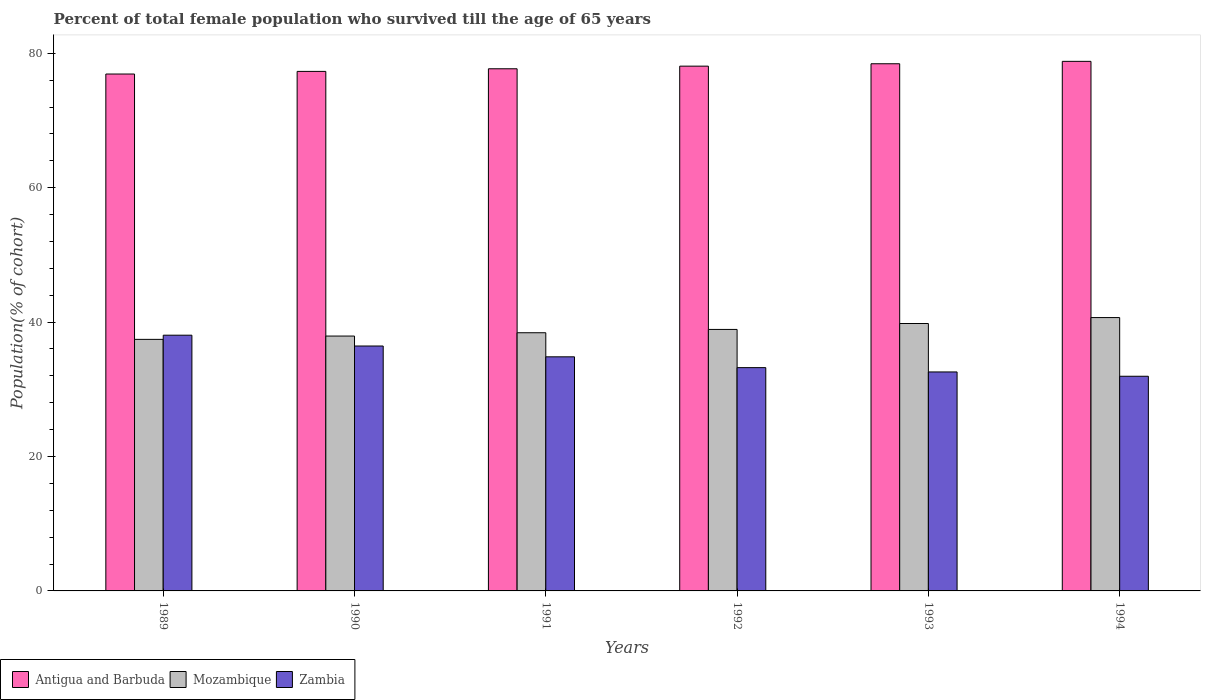How many different coloured bars are there?
Give a very brief answer. 3. How many groups of bars are there?
Make the answer very short. 6. Are the number of bars per tick equal to the number of legend labels?
Offer a terse response. Yes. Are the number of bars on each tick of the X-axis equal?
Offer a very short reply. Yes. How many bars are there on the 2nd tick from the right?
Your answer should be compact. 3. What is the label of the 4th group of bars from the left?
Provide a short and direct response. 1992. In how many cases, is the number of bars for a given year not equal to the number of legend labels?
Offer a very short reply. 0. What is the percentage of total female population who survived till the age of 65 years in Zambia in 1992?
Provide a short and direct response. 33.23. Across all years, what is the maximum percentage of total female population who survived till the age of 65 years in Antigua and Barbuda?
Provide a succinct answer. 78.8. Across all years, what is the minimum percentage of total female population who survived till the age of 65 years in Mozambique?
Make the answer very short. 37.43. In which year was the percentage of total female population who survived till the age of 65 years in Zambia maximum?
Your answer should be compact. 1989. In which year was the percentage of total female population who survived till the age of 65 years in Antigua and Barbuda minimum?
Provide a short and direct response. 1989. What is the total percentage of total female population who survived till the age of 65 years in Antigua and Barbuda in the graph?
Keep it short and to the point. 467.25. What is the difference between the percentage of total female population who survived till the age of 65 years in Zambia in 1990 and that in 1991?
Your answer should be compact. 1.61. What is the difference between the percentage of total female population who survived till the age of 65 years in Zambia in 1993 and the percentage of total female population who survived till the age of 65 years in Antigua and Barbuda in 1991?
Ensure brevity in your answer.  -45.11. What is the average percentage of total female population who survived till the age of 65 years in Antigua and Barbuda per year?
Keep it short and to the point. 77.88. In the year 1991, what is the difference between the percentage of total female population who survived till the age of 65 years in Zambia and percentage of total female population who survived till the age of 65 years in Mozambique?
Offer a very short reply. -3.58. What is the ratio of the percentage of total female population who survived till the age of 65 years in Antigua and Barbuda in 1990 to that in 1994?
Provide a short and direct response. 0.98. Is the percentage of total female population who survived till the age of 65 years in Mozambique in 1993 less than that in 1994?
Make the answer very short. Yes. Is the difference between the percentage of total female population who survived till the age of 65 years in Zambia in 1993 and 1994 greater than the difference between the percentage of total female population who survived till the age of 65 years in Mozambique in 1993 and 1994?
Provide a succinct answer. Yes. What is the difference between the highest and the second highest percentage of total female population who survived till the age of 65 years in Zambia?
Give a very brief answer. 1.61. What is the difference between the highest and the lowest percentage of total female population who survived till the age of 65 years in Zambia?
Your answer should be very brief. 6.11. In how many years, is the percentage of total female population who survived till the age of 65 years in Antigua and Barbuda greater than the average percentage of total female population who survived till the age of 65 years in Antigua and Barbuda taken over all years?
Provide a succinct answer. 3. Is the sum of the percentage of total female population who survived till the age of 65 years in Antigua and Barbuda in 1991 and 1992 greater than the maximum percentage of total female population who survived till the age of 65 years in Zambia across all years?
Offer a terse response. Yes. What does the 2nd bar from the left in 1989 represents?
Your answer should be very brief. Mozambique. What does the 1st bar from the right in 1993 represents?
Give a very brief answer. Zambia. How many bars are there?
Your answer should be very brief. 18. Does the graph contain grids?
Offer a very short reply. No. Where does the legend appear in the graph?
Keep it short and to the point. Bottom left. What is the title of the graph?
Keep it short and to the point. Percent of total female population who survived till the age of 65 years. Does "Tonga" appear as one of the legend labels in the graph?
Give a very brief answer. No. What is the label or title of the Y-axis?
Ensure brevity in your answer.  Population(% of cohort). What is the Population(% of cohort) in Antigua and Barbuda in 1989?
Give a very brief answer. 76.92. What is the Population(% of cohort) in Mozambique in 1989?
Your answer should be compact. 37.43. What is the Population(% of cohort) in Zambia in 1989?
Offer a very short reply. 38.05. What is the Population(% of cohort) in Antigua and Barbuda in 1990?
Keep it short and to the point. 77.31. What is the Population(% of cohort) of Mozambique in 1990?
Offer a terse response. 37.92. What is the Population(% of cohort) of Zambia in 1990?
Your answer should be compact. 36.44. What is the Population(% of cohort) in Antigua and Barbuda in 1991?
Your answer should be very brief. 77.7. What is the Population(% of cohort) of Mozambique in 1991?
Your answer should be very brief. 38.42. What is the Population(% of cohort) of Zambia in 1991?
Your answer should be very brief. 34.84. What is the Population(% of cohort) of Antigua and Barbuda in 1992?
Ensure brevity in your answer.  78.09. What is the Population(% of cohort) of Mozambique in 1992?
Your answer should be compact. 38.91. What is the Population(% of cohort) in Zambia in 1992?
Offer a terse response. 33.23. What is the Population(% of cohort) of Antigua and Barbuda in 1993?
Give a very brief answer. 78.44. What is the Population(% of cohort) of Mozambique in 1993?
Make the answer very short. 39.79. What is the Population(% of cohort) in Zambia in 1993?
Your answer should be compact. 32.58. What is the Population(% of cohort) of Antigua and Barbuda in 1994?
Offer a terse response. 78.8. What is the Population(% of cohort) in Mozambique in 1994?
Make the answer very short. 40.67. What is the Population(% of cohort) of Zambia in 1994?
Offer a very short reply. 31.94. Across all years, what is the maximum Population(% of cohort) in Antigua and Barbuda?
Give a very brief answer. 78.8. Across all years, what is the maximum Population(% of cohort) in Mozambique?
Keep it short and to the point. 40.67. Across all years, what is the maximum Population(% of cohort) in Zambia?
Provide a short and direct response. 38.05. Across all years, what is the minimum Population(% of cohort) in Antigua and Barbuda?
Make the answer very short. 76.92. Across all years, what is the minimum Population(% of cohort) of Mozambique?
Provide a short and direct response. 37.43. Across all years, what is the minimum Population(% of cohort) of Zambia?
Offer a terse response. 31.94. What is the total Population(% of cohort) of Antigua and Barbuda in the graph?
Your answer should be very brief. 467.25. What is the total Population(% of cohort) in Mozambique in the graph?
Ensure brevity in your answer.  233.15. What is the total Population(% of cohort) of Zambia in the graph?
Give a very brief answer. 207.09. What is the difference between the Population(% of cohort) of Antigua and Barbuda in 1989 and that in 1990?
Keep it short and to the point. -0.39. What is the difference between the Population(% of cohort) in Mozambique in 1989 and that in 1990?
Make the answer very short. -0.49. What is the difference between the Population(% of cohort) in Zambia in 1989 and that in 1990?
Your answer should be very brief. 1.61. What is the difference between the Population(% of cohort) in Antigua and Barbuda in 1989 and that in 1991?
Provide a short and direct response. -0.78. What is the difference between the Population(% of cohort) in Mozambique in 1989 and that in 1991?
Keep it short and to the point. -0.99. What is the difference between the Population(% of cohort) of Zambia in 1989 and that in 1991?
Provide a short and direct response. 3.22. What is the difference between the Population(% of cohort) of Antigua and Barbuda in 1989 and that in 1992?
Your response must be concise. -1.17. What is the difference between the Population(% of cohort) in Mozambique in 1989 and that in 1992?
Your answer should be very brief. -1.48. What is the difference between the Population(% of cohort) of Zambia in 1989 and that in 1992?
Give a very brief answer. 4.83. What is the difference between the Population(% of cohort) in Antigua and Barbuda in 1989 and that in 1993?
Offer a terse response. -1.53. What is the difference between the Population(% of cohort) in Mozambique in 1989 and that in 1993?
Your answer should be compact. -2.36. What is the difference between the Population(% of cohort) of Zambia in 1989 and that in 1993?
Offer a terse response. 5.47. What is the difference between the Population(% of cohort) in Antigua and Barbuda in 1989 and that in 1994?
Your answer should be very brief. -1.89. What is the difference between the Population(% of cohort) of Mozambique in 1989 and that in 1994?
Your response must be concise. -3.24. What is the difference between the Population(% of cohort) of Zambia in 1989 and that in 1994?
Your answer should be very brief. 6.11. What is the difference between the Population(% of cohort) in Antigua and Barbuda in 1990 and that in 1991?
Your answer should be compact. -0.39. What is the difference between the Population(% of cohort) of Mozambique in 1990 and that in 1991?
Provide a succinct answer. -0.49. What is the difference between the Population(% of cohort) of Zambia in 1990 and that in 1991?
Your answer should be compact. 1.61. What is the difference between the Population(% of cohort) in Antigua and Barbuda in 1990 and that in 1992?
Give a very brief answer. -0.78. What is the difference between the Population(% of cohort) of Mozambique in 1990 and that in 1992?
Give a very brief answer. -0.99. What is the difference between the Population(% of cohort) of Zambia in 1990 and that in 1992?
Ensure brevity in your answer.  3.22. What is the difference between the Population(% of cohort) in Antigua and Barbuda in 1990 and that in 1993?
Your answer should be compact. -1.14. What is the difference between the Population(% of cohort) in Mozambique in 1990 and that in 1993?
Offer a terse response. -1.87. What is the difference between the Population(% of cohort) in Zambia in 1990 and that in 1993?
Make the answer very short. 3.86. What is the difference between the Population(% of cohort) of Antigua and Barbuda in 1990 and that in 1994?
Keep it short and to the point. -1.5. What is the difference between the Population(% of cohort) in Mozambique in 1990 and that in 1994?
Make the answer very short. -2.75. What is the difference between the Population(% of cohort) of Zambia in 1990 and that in 1994?
Provide a short and direct response. 4.5. What is the difference between the Population(% of cohort) of Antigua and Barbuda in 1991 and that in 1992?
Your answer should be compact. -0.39. What is the difference between the Population(% of cohort) in Mozambique in 1991 and that in 1992?
Keep it short and to the point. -0.49. What is the difference between the Population(% of cohort) in Zambia in 1991 and that in 1992?
Ensure brevity in your answer.  1.61. What is the difference between the Population(% of cohort) in Antigua and Barbuda in 1991 and that in 1993?
Give a very brief answer. -0.75. What is the difference between the Population(% of cohort) of Mozambique in 1991 and that in 1993?
Offer a very short reply. -1.38. What is the difference between the Population(% of cohort) of Zambia in 1991 and that in 1993?
Make the answer very short. 2.25. What is the difference between the Population(% of cohort) in Antigua and Barbuda in 1991 and that in 1994?
Your response must be concise. -1.1. What is the difference between the Population(% of cohort) of Mozambique in 1991 and that in 1994?
Your response must be concise. -2.26. What is the difference between the Population(% of cohort) in Zambia in 1991 and that in 1994?
Offer a very short reply. 2.89. What is the difference between the Population(% of cohort) in Antigua and Barbuda in 1992 and that in 1993?
Offer a terse response. -0.36. What is the difference between the Population(% of cohort) in Mozambique in 1992 and that in 1993?
Your answer should be very brief. -0.88. What is the difference between the Population(% of cohort) in Zambia in 1992 and that in 1993?
Provide a short and direct response. 0.64. What is the difference between the Population(% of cohort) of Antigua and Barbuda in 1992 and that in 1994?
Your answer should be very brief. -0.71. What is the difference between the Population(% of cohort) in Mozambique in 1992 and that in 1994?
Offer a terse response. -1.77. What is the difference between the Population(% of cohort) in Zambia in 1992 and that in 1994?
Provide a succinct answer. 1.28. What is the difference between the Population(% of cohort) of Antigua and Barbuda in 1993 and that in 1994?
Your response must be concise. -0.36. What is the difference between the Population(% of cohort) of Mozambique in 1993 and that in 1994?
Keep it short and to the point. -0.88. What is the difference between the Population(% of cohort) of Zambia in 1993 and that in 1994?
Give a very brief answer. 0.64. What is the difference between the Population(% of cohort) of Antigua and Barbuda in 1989 and the Population(% of cohort) of Mozambique in 1990?
Give a very brief answer. 38.99. What is the difference between the Population(% of cohort) in Antigua and Barbuda in 1989 and the Population(% of cohort) in Zambia in 1990?
Provide a succinct answer. 40.47. What is the difference between the Population(% of cohort) in Mozambique in 1989 and the Population(% of cohort) in Zambia in 1990?
Give a very brief answer. 0.99. What is the difference between the Population(% of cohort) in Antigua and Barbuda in 1989 and the Population(% of cohort) in Mozambique in 1991?
Offer a very short reply. 38.5. What is the difference between the Population(% of cohort) of Antigua and Barbuda in 1989 and the Population(% of cohort) of Zambia in 1991?
Your answer should be very brief. 42.08. What is the difference between the Population(% of cohort) of Mozambique in 1989 and the Population(% of cohort) of Zambia in 1991?
Ensure brevity in your answer.  2.6. What is the difference between the Population(% of cohort) in Antigua and Barbuda in 1989 and the Population(% of cohort) in Mozambique in 1992?
Provide a short and direct response. 38.01. What is the difference between the Population(% of cohort) in Antigua and Barbuda in 1989 and the Population(% of cohort) in Zambia in 1992?
Provide a short and direct response. 43.69. What is the difference between the Population(% of cohort) of Mozambique in 1989 and the Population(% of cohort) of Zambia in 1992?
Your answer should be very brief. 4.21. What is the difference between the Population(% of cohort) in Antigua and Barbuda in 1989 and the Population(% of cohort) in Mozambique in 1993?
Your answer should be very brief. 37.12. What is the difference between the Population(% of cohort) in Antigua and Barbuda in 1989 and the Population(% of cohort) in Zambia in 1993?
Make the answer very short. 44.33. What is the difference between the Population(% of cohort) in Mozambique in 1989 and the Population(% of cohort) in Zambia in 1993?
Your response must be concise. 4.85. What is the difference between the Population(% of cohort) in Antigua and Barbuda in 1989 and the Population(% of cohort) in Mozambique in 1994?
Keep it short and to the point. 36.24. What is the difference between the Population(% of cohort) of Antigua and Barbuda in 1989 and the Population(% of cohort) of Zambia in 1994?
Your response must be concise. 44.97. What is the difference between the Population(% of cohort) of Mozambique in 1989 and the Population(% of cohort) of Zambia in 1994?
Keep it short and to the point. 5.49. What is the difference between the Population(% of cohort) of Antigua and Barbuda in 1990 and the Population(% of cohort) of Mozambique in 1991?
Provide a short and direct response. 38.89. What is the difference between the Population(% of cohort) in Antigua and Barbuda in 1990 and the Population(% of cohort) in Zambia in 1991?
Offer a very short reply. 42.47. What is the difference between the Population(% of cohort) in Mozambique in 1990 and the Population(% of cohort) in Zambia in 1991?
Your response must be concise. 3.09. What is the difference between the Population(% of cohort) of Antigua and Barbuda in 1990 and the Population(% of cohort) of Mozambique in 1992?
Make the answer very short. 38.4. What is the difference between the Population(% of cohort) of Antigua and Barbuda in 1990 and the Population(% of cohort) of Zambia in 1992?
Provide a short and direct response. 44.08. What is the difference between the Population(% of cohort) in Mozambique in 1990 and the Population(% of cohort) in Zambia in 1992?
Offer a terse response. 4.7. What is the difference between the Population(% of cohort) of Antigua and Barbuda in 1990 and the Population(% of cohort) of Mozambique in 1993?
Give a very brief answer. 37.51. What is the difference between the Population(% of cohort) in Antigua and Barbuda in 1990 and the Population(% of cohort) in Zambia in 1993?
Provide a short and direct response. 44.72. What is the difference between the Population(% of cohort) of Mozambique in 1990 and the Population(% of cohort) of Zambia in 1993?
Provide a succinct answer. 5.34. What is the difference between the Population(% of cohort) in Antigua and Barbuda in 1990 and the Population(% of cohort) in Mozambique in 1994?
Provide a succinct answer. 36.63. What is the difference between the Population(% of cohort) of Antigua and Barbuda in 1990 and the Population(% of cohort) of Zambia in 1994?
Your answer should be compact. 45.36. What is the difference between the Population(% of cohort) in Mozambique in 1990 and the Population(% of cohort) in Zambia in 1994?
Your answer should be compact. 5.98. What is the difference between the Population(% of cohort) in Antigua and Barbuda in 1991 and the Population(% of cohort) in Mozambique in 1992?
Give a very brief answer. 38.79. What is the difference between the Population(% of cohort) in Antigua and Barbuda in 1991 and the Population(% of cohort) in Zambia in 1992?
Your answer should be very brief. 44.47. What is the difference between the Population(% of cohort) in Mozambique in 1991 and the Population(% of cohort) in Zambia in 1992?
Keep it short and to the point. 5.19. What is the difference between the Population(% of cohort) of Antigua and Barbuda in 1991 and the Population(% of cohort) of Mozambique in 1993?
Your answer should be very brief. 37.9. What is the difference between the Population(% of cohort) in Antigua and Barbuda in 1991 and the Population(% of cohort) in Zambia in 1993?
Your response must be concise. 45.11. What is the difference between the Population(% of cohort) of Mozambique in 1991 and the Population(% of cohort) of Zambia in 1993?
Offer a terse response. 5.83. What is the difference between the Population(% of cohort) in Antigua and Barbuda in 1991 and the Population(% of cohort) in Mozambique in 1994?
Offer a very short reply. 37.02. What is the difference between the Population(% of cohort) of Antigua and Barbuda in 1991 and the Population(% of cohort) of Zambia in 1994?
Give a very brief answer. 45.75. What is the difference between the Population(% of cohort) in Mozambique in 1991 and the Population(% of cohort) in Zambia in 1994?
Your response must be concise. 6.47. What is the difference between the Population(% of cohort) in Antigua and Barbuda in 1992 and the Population(% of cohort) in Mozambique in 1993?
Your answer should be very brief. 38.29. What is the difference between the Population(% of cohort) of Antigua and Barbuda in 1992 and the Population(% of cohort) of Zambia in 1993?
Your response must be concise. 45.5. What is the difference between the Population(% of cohort) in Mozambique in 1992 and the Population(% of cohort) in Zambia in 1993?
Offer a very short reply. 6.33. What is the difference between the Population(% of cohort) of Antigua and Barbuda in 1992 and the Population(% of cohort) of Mozambique in 1994?
Provide a succinct answer. 37.41. What is the difference between the Population(% of cohort) of Antigua and Barbuda in 1992 and the Population(% of cohort) of Zambia in 1994?
Provide a succinct answer. 46.14. What is the difference between the Population(% of cohort) in Mozambique in 1992 and the Population(% of cohort) in Zambia in 1994?
Provide a short and direct response. 6.97. What is the difference between the Population(% of cohort) of Antigua and Barbuda in 1993 and the Population(% of cohort) of Mozambique in 1994?
Keep it short and to the point. 37.77. What is the difference between the Population(% of cohort) in Antigua and Barbuda in 1993 and the Population(% of cohort) in Zambia in 1994?
Your response must be concise. 46.5. What is the difference between the Population(% of cohort) in Mozambique in 1993 and the Population(% of cohort) in Zambia in 1994?
Your answer should be very brief. 7.85. What is the average Population(% of cohort) of Antigua and Barbuda per year?
Offer a very short reply. 77.88. What is the average Population(% of cohort) of Mozambique per year?
Keep it short and to the point. 38.86. What is the average Population(% of cohort) of Zambia per year?
Your response must be concise. 34.51. In the year 1989, what is the difference between the Population(% of cohort) in Antigua and Barbuda and Population(% of cohort) in Mozambique?
Give a very brief answer. 39.48. In the year 1989, what is the difference between the Population(% of cohort) in Antigua and Barbuda and Population(% of cohort) in Zambia?
Your answer should be very brief. 38.86. In the year 1989, what is the difference between the Population(% of cohort) in Mozambique and Population(% of cohort) in Zambia?
Make the answer very short. -0.62. In the year 1990, what is the difference between the Population(% of cohort) of Antigua and Barbuda and Population(% of cohort) of Mozambique?
Keep it short and to the point. 39.38. In the year 1990, what is the difference between the Population(% of cohort) in Antigua and Barbuda and Population(% of cohort) in Zambia?
Offer a very short reply. 40.86. In the year 1990, what is the difference between the Population(% of cohort) of Mozambique and Population(% of cohort) of Zambia?
Your answer should be very brief. 1.48. In the year 1991, what is the difference between the Population(% of cohort) in Antigua and Barbuda and Population(% of cohort) in Mozambique?
Make the answer very short. 39.28. In the year 1991, what is the difference between the Population(% of cohort) of Antigua and Barbuda and Population(% of cohort) of Zambia?
Your answer should be compact. 42.86. In the year 1991, what is the difference between the Population(% of cohort) of Mozambique and Population(% of cohort) of Zambia?
Make the answer very short. 3.58. In the year 1992, what is the difference between the Population(% of cohort) in Antigua and Barbuda and Population(% of cohort) in Mozambique?
Offer a terse response. 39.18. In the year 1992, what is the difference between the Population(% of cohort) in Antigua and Barbuda and Population(% of cohort) in Zambia?
Provide a succinct answer. 44.86. In the year 1992, what is the difference between the Population(% of cohort) in Mozambique and Population(% of cohort) in Zambia?
Keep it short and to the point. 5.68. In the year 1993, what is the difference between the Population(% of cohort) in Antigua and Barbuda and Population(% of cohort) in Mozambique?
Provide a succinct answer. 38.65. In the year 1993, what is the difference between the Population(% of cohort) of Antigua and Barbuda and Population(% of cohort) of Zambia?
Provide a succinct answer. 45.86. In the year 1993, what is the difference between the Population(% of cohort) of Mozambique and Population(% of cohort) of Zambia?
Make the answer very short. 7.21. In the year 1994, what is the difference between the Population(% of cohort) in Antigua and Barbuda and Population(% of cohort) in Mozambique?
Keep it short and to the point. 38.13. In the year 1994, what is the difference between the Population(% of cohort) in Antigua and Barbuda and Population(% of cohort) in Zambia?
Give a very brief answer. 46.86. In the year 1994, what is the difference between the Population(% of cohort) in Mozambique and Population(% of cohort) in Zambia?
Provide a succinct answer. 8.73. What is the ratio of the Population(% of cohort) in Zambia in 1989 to that in 1990?
Keep it short and to the point. 1.04. What is the ratio of the Population(% of cohort) in Antigua and Barbuda in 1989 to that in 1991?
Give a very brief answer. 0.99. What is the ratio of the Population(% of cohort) in Mozambique in 1989 to that in 1991?
Give a very brief answer. 0.97. What is the ratio of the Population(% of cohort) in Zambia in 1989 to that in 1991?
Provide a short and direct response. 1.09. What is the ratio of the Population(% of cohort) of Zambia in 1989 to that in 1992?
Your response must be concise. 1.15. What is the ratio of the Population(% of cohort) of Antigua and Barbuda in 1989 to that in 1993?
Offer a terse response. 0.98. What is the ratio of the Population(% of cohort) of Mozambique in 1989 to that in 1993?
Your response must be concise. 0.94. What is the ratio of the Population(% of cohort) in Zambia in 1989 to that in 1993?
Your response must be concise. 1.17. What is the ratio of the Population(% of cohort) in Antigua and Barbuda in 1989 to that in 1994?
Make the answer very short. 0.98. What is the ratio of the Population(% of cohort) of Mozambique in 1989 to that in 1994?
Your answer should be very brief. 0.92. What is the ratio of the Population(% of cohort) of Zambia in 1989 to that in 1994?
Offer a terse response. 1.19. What is the ratio of the Population(% of cohort) in Antigua and Barbuda in 1990 to that in 1991?
Keep it short and to the point. 0.99. What is the ratio of the Population(% of cohort) in Mozambique in 1990 to that in 1991?
Offer a very short reply. 0.99. What is the ratio of the Population(% of cohort) of Zambia in 1990 to that in 1991?
Keep it short and to the point. 1.05. What is the ratio of the Population(% of cohort) of Mozambique in 1990 to that in 1992?
Make the answer very short. 0.97. What is the ratio of the Population(% of cohort) in Zambia in 1990 to that in 1992?
Ensure brevity in your answer.  1.1. What is the ratio of the Population(% of cohort) in Antigua and Barbuda in 1990 to that in 1993?
Your response must be concise. 0.99. What is the ratio of the Population(% of cohort) in Mozambique in 1990 to that in 1993?
Offer a very short reply. 0.95. What is the ratio of the Population(% of cohort) of Zambia in 1990 to that in 1993?
Offer a very short reply. 1.12. What is the ratio of the Population(% of cohort) of Antigua and Barbuda in 1990 to that in 1994?
Your answer should be very brief. 0.98. What is the ratio of the Population(% of cohort) in Mozambique in 1990 to that in 1994?
Your answer should be compact. 0.93. What is the ratio of the Population(% of cohort) in Zambia in 1990 to that in 1994?
Keep it short and to the point. 1.14. What is the ratio of the Population(% of cohort) in Mozambique in 1991 to that in 1992?
Keep it short and to the point. 0.99. What is the ratio of the Population(% of cohort) of Zambia in 1991 to that in 1992?
Provide a short and direct response. 1.05. What is the ratio of the Population(% of cohort) in Mozambique in 1991 to that in 1993?
Your answer should be very brief. 0.97. What is the ratio of the Population(% of cohort) in Zambia in 1991 to that in 1993?
Provide a short and direct response. 1.07. What is the ratio of the Population(% of cohort) in Antigua and Barbuda in 1991 to that in 1994?
Your response must be concise. 0.99. What is the ratio of the Population(% of cohort) of Mozambique in 1991 to that in 1994?
Keep it short and to the point. 0.94. What is the ratio of the Population(% of cohort) in Zambia in 1991 to that in 1994?
Provide a short and direct response. 1.09. What is the ratio of the Population(% of cohort) of Mozambique in 1992 to that in 1993?
Ensure brevity in your answer.  0.98. What is the ratio of the Population(% of cohort) of Zambia in 1992 to that in 1993?
Your answer should be very brief. 1.02. What is the ratio of the Population(% of cohort) of Antigua and Barbuda in 1992 to that in 1994?
Offer a terse response. 0.99. What is the ratio of the Population(% of cohort) in Mozambique in 1992 to that in 1994?
Ensure brevity in your answer.  0.96. What is the ratio of the Population(% of cohort) in Zambia in 1992 to that in 1994?
Provide a succinct answer. 1.04. What is the ratio of the Population(% of cohort) in Mozambique in 1993 to that in 1994?
Keep it short and to the point. 0.98. What is the ratio of the Population(% of cohort) in Zambia in 1993 to that in 1994?
Give a very brief answer. 1.02. What is the difference between the highest and the second highest Population(% of cohort) in Antigua and Barbuda?
Provide a short and direct response. 0.36. What is the difference between the highest and the second highest Population(% of cohort) of Mozambique?
Make the answer very short. 0.88. What is the difference between the highest and the second highest Population(% of cohort) in Zambia?
Your response must be concise. 1.61. What is the difference between the highest and the lowest Population(% of cohort) of Antigua and Barbuda?
Provide a short and direct response. 1.89. What is the difference between the highest and the lowest Population(% of cohort) in Mozambique?
Your answer should be compact. 3.24. What is the difference between the highest and the lowest Population(% of cohort) of Zambia?
Offer a terse response. 6.11. 